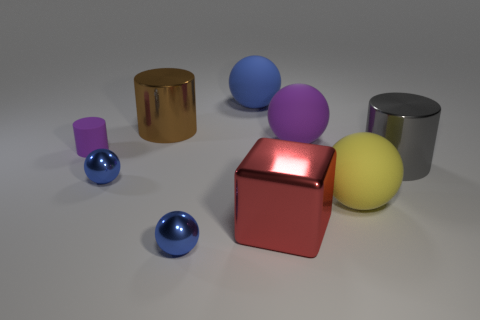What material is the large ball behind the purple ball?
Your response must be concise. Rubber. Is the number of large gray metal things greater than the number of tiny gray rubber cylinders?
Give a very brief answer. Yes. Is the shape of the tiny blue shiny object behind the big red metal thing the same as  the yellow rubber object?
Your answer should be very brief. Yes. How many big objects are behind the big cube and on the left side of the big gray thing?
Keep it short and to the point. 4. How many other small blue objects have the same shape as the blue rubber object?
Your response must be concise. 2. What is the color of the large cylinder on the left side of the big sphere that is left of the big cube?
Provide a succinct answer. Brown. Does the gray metallic thing have the same shape as the big metal object behind the small cylinder?
Your answer should be compact. Yes. The large red block in front of the metal cylinder that is to the left of the blue rubber ball that is behind the purple sphere is made of what material?
Offer a very short reply. Metal. Is there a blue shiny sphere of the same size as the red metallic block?
Keep it short and to the point. No. There is a blue thing that is made of the same material as the big purple thing; what is its size?
Make the answer very short. Large. 